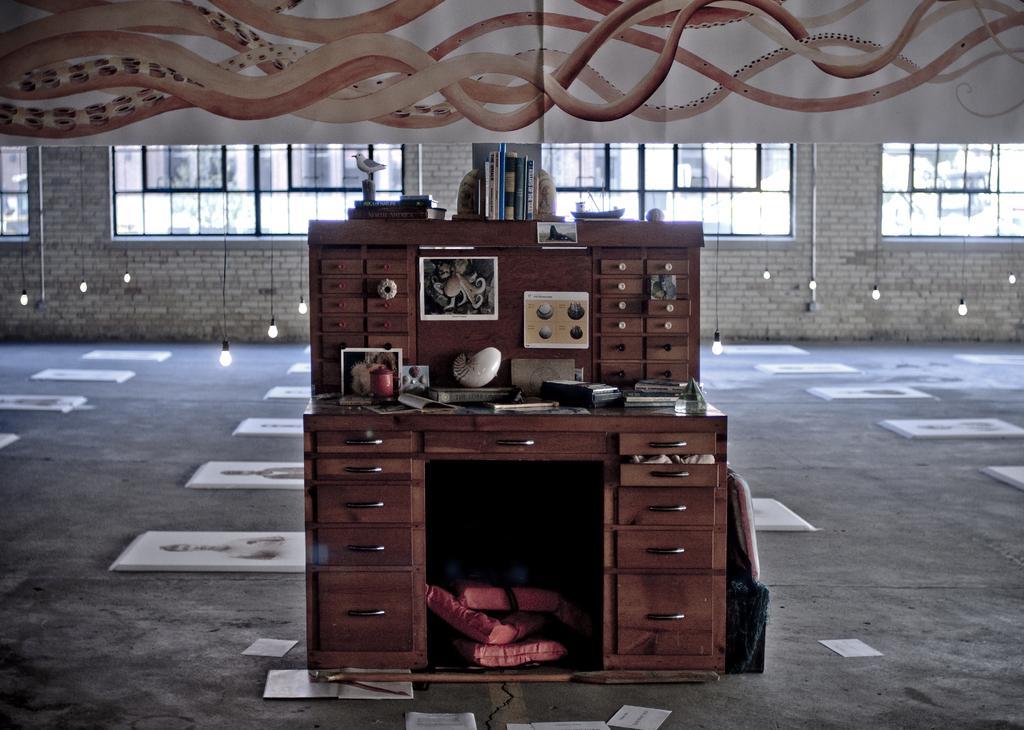Can you describe this image briefly? In the middle of the picture, we see the drawer chest cabinet on which papers, photo frames and some other items are placed. Behind that, we see some posters pasted on it. On top of it, we see many books are placed. At the bottom, we see the floor and we see some objects in red color are placed in the drawer. Behind that, we see the bulbs. In the background, we see a wall and windows. At the top, we see a white sheet or a banner. 